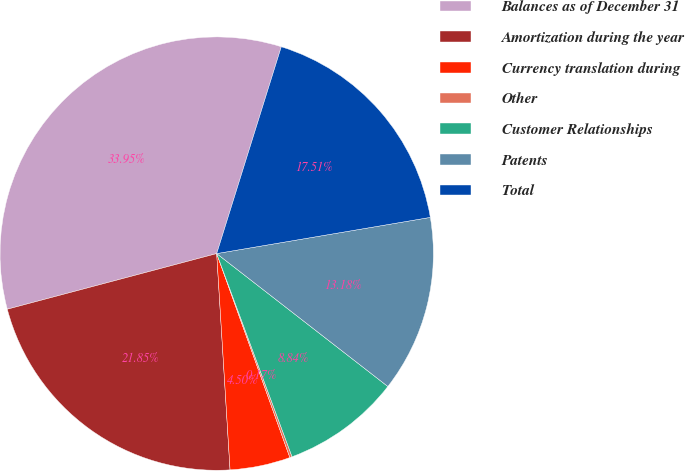<chart> <loc_0><loc_0><loc_500><loc_500><pie_chart><fcel>Balances as of December 31<fcel>Amortization during the year<fcel>Currency translation during<fcel>Other<fcel>Customer Relationships<fcel>Patents<fcel>Total<nl><fcel>33.95%<fcel>21.85%<fcel>4.5%<fcel>0.17%<fcel>8.84%<fcel>13.18%<fcel>17.51%<nl></chart> 